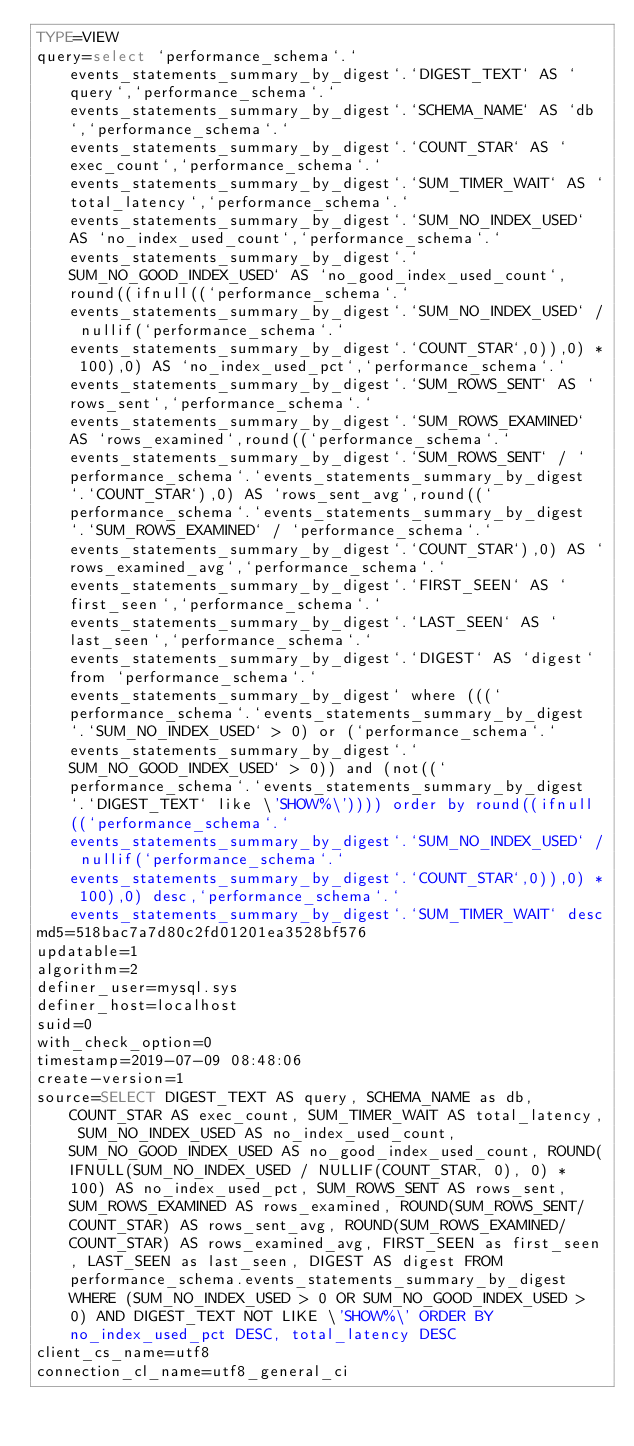<code> <loc_0><loc_0><loc_500><loc_500><_VisualBasic_>TYPE=VIEW
query=select `performance_schema`.`events_statements_summary_by_digest`.`DIGEST_TEXT` AS `query`,`performance_schema`.`events_statements_summary_by_digest`.`SCHEMA_NAME` AS `db`,`performance_schema`.`events_statements_summary_by_digest`.`COUNT_STAR` AS `exec_count`,`performance_schema`.`events_statements_summary_by_digest`.`SUM_TIMER_WAIT` AS `total_latency`,`performance_schema`.`events_statements_summary_by_digest`.`SUM_NO_INDEX_USED` AS `no_index_used_count`,`performance_schema`.`events_statements_summary_by_digest`.`SUM_NO_GOOD_INDEX_USED` AS `no_good_index_used_count`,round((ifnull((`performance_schema`.`events_statements_summary_by_digest`.`SUM_NO_INDEX_USED` / nullif(`performance_schema`.`events_statements_summary_by_digest`.`COUNT_STAR`,0)),0) * 100),0) AS `no_index_used_pct`,`performance_schema`.`events_statements_summary_by_digest`.`SUM_ROWS_SENT` AS `rows_sent`,`performance_schema`.`events_statements_summary_by_digest`.`SUM_ROWS_EXAMINED` AS `rows_examined`,round((`performance_schema`.`events_statements_summary_by_digest`.`SUM_ROWS_SENT` / `performance_schema`.`events_statements_summary_by_digest`.`COUNT_STAR`),0) AS `rows_sent_avg`,round((`performance_schema`.`events_statements_summary_by_digest`.`SUM_ROWS_EXAMINED` / `performance_schema`.`events_statements_summary_by_digest`.`COUNT_STAR`),0) AS `rows_examined_avg`,`performance_schema`.`events_statements_summary_by_digest`.`FIRST_SEEN` AS `first_seen`,`performance_schema`.`events_statements_summary_by_digest`.`LAST_SEEN` AS `last_seen`,`performance_schema`.`events_statements_summary_by_digest`.`DIGEST` AS `digest` from `performance_schema`.`events_statements_summary_by_digest` where (((`performance_schema`.`events_statements_summary_by_digest`.`SUM_NO_INDEX_USED` > 0) or (`performance_schema`.`events_statements_summary_by_digest`.`SUM_NO_GOOD_INDEX_USED` > 0)) and (not((`performance_schema`.`events_statements_summary_by_digest`.`DIGEST_TEXT` like \'SHOW%\')))) order by round((ifnull((`performance_schema`.`events_statements_summary_by_digest`.`SUM_NO_INDEX_USED` / nullif(`performance_schema`.`events_statements_summary_by_digest`.`COUNT_STAR`,0)),0) * 100),0) desc,`performance_schema`.`events_statements_summary_by_digest`.`SUM_TIMER_WAIT` desc
md5=518bac7a7d80c2fd01201ea3528bf576
updatable=1
algorithm=2
definer_user=mysql.sys
definer_host=localhost
suid=0
with_check_option=0
timestamp=2019-07-09 08:48:06
create-version=1
source=SELECT DIGEST_TEXT AS query, SCHEMA_NAME as db, COUNT_STAR AS exec_count, SUM_TIMER_WAIT AS total_latency, SUM_NO_INDEX_USED AS no_index_used_count, SUM_NO_GOOD_INDEX_USED AS no_good_index_used_count, ROUND(IFNULL(SUM_NO_INDEX_USED / NULLIF(COUNT_STAR, 0), 0) * 100) AS no_index_used_pct, SUM_ROWS_SENT AS rows_sent, SUM_ROWS_EXAMINED AS rows_examined, ROUND(SUM_ROWS_SENT/COUNT_STAR) AS rows_sent_avg, ROUND(SUM_ROWS_EXAMINED/COUNT_STAR) AS rows_examined_avg, FIRST_SEEN as first_seen, LAST_SEEN as last_seen, DIGEST AS digest FROM performance_schema.events_statements_summary_by_digest WHERE (SUM_NO_INDEX_USED > 0 OR SUM_NO_GOOD_INDEX_USED > 0) AND DIGEST_TEXT NOT LIKE \'SHOW%\' ORDER BY no_index_used_pct DESC, total_latency DESC
client_cs_name=utf8
connection_cl_name=utf8_general_ci</code> 